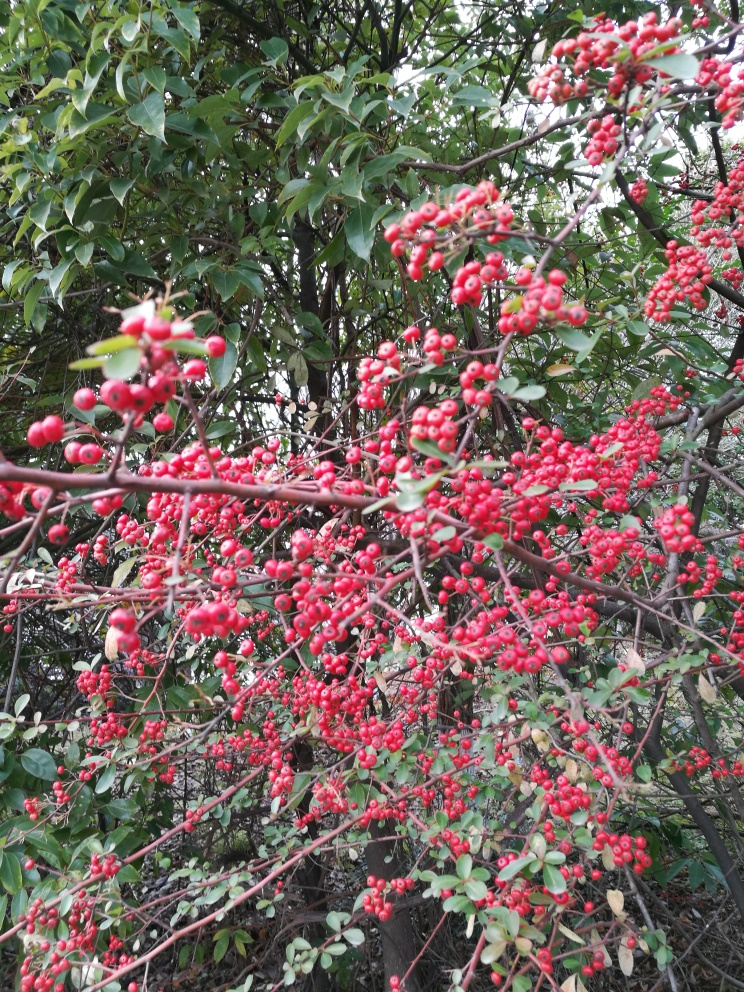Are the colors vivid?
A. No
B. Yes
Answer with the option's letter from the given choices directly.
 B. 